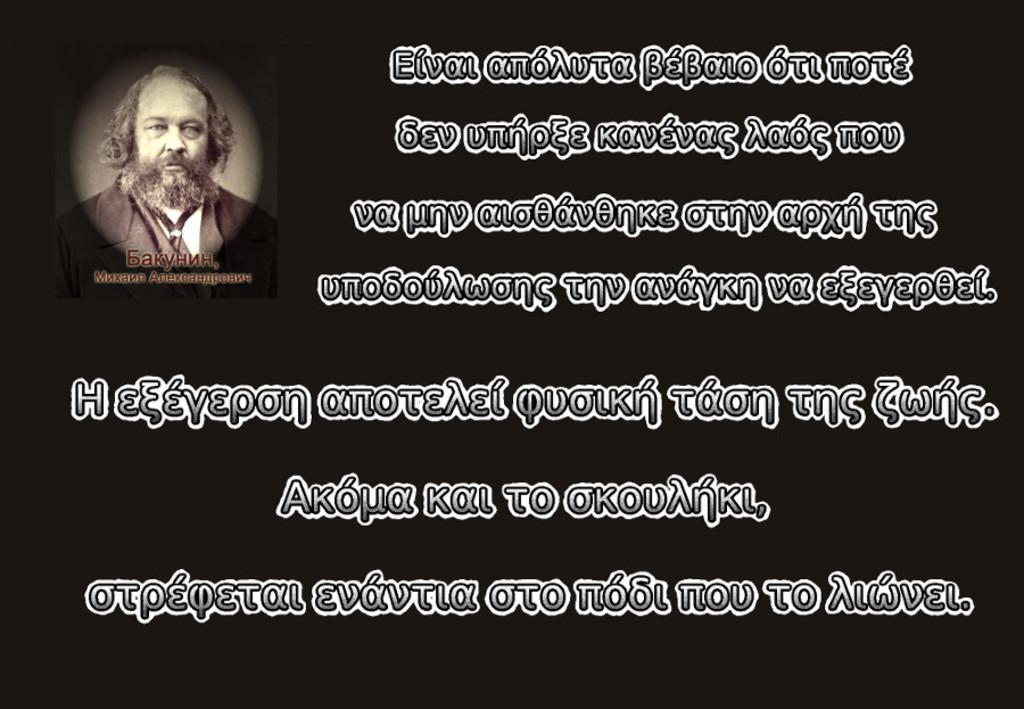What is present in the image that contains information or a message? There is a poster in the image that contains information or a message. What type of content can be found on the poster? The poster contains text. Is there any visual element on the poster besides the text? Yes, there is an image of a person on the poster. What type of toothpaste is being advertised on the poster? There is no toothpaste present on the poster; it contains text and an image of a person. Can you tell me the weight of the person depicted on the poster? The weight of the person depicted on the poster cannot be determined from the image, as it does not include a scale or any information about the person's weight. 